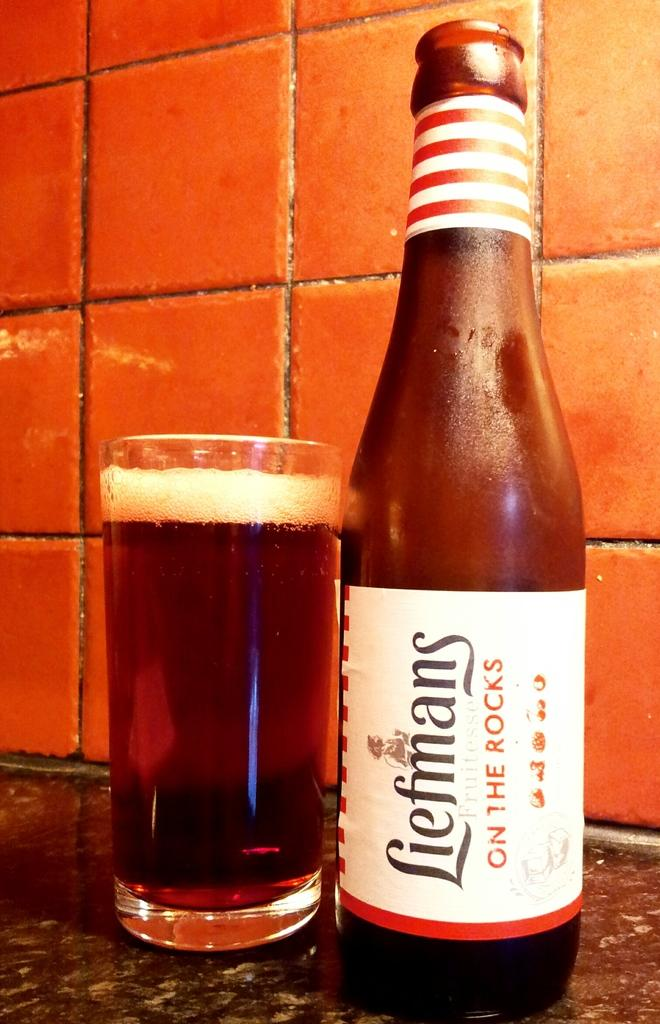<image>
Offer a succinct explanation of the picture presented. A bottle of chilled Liefmans served on the counter. 